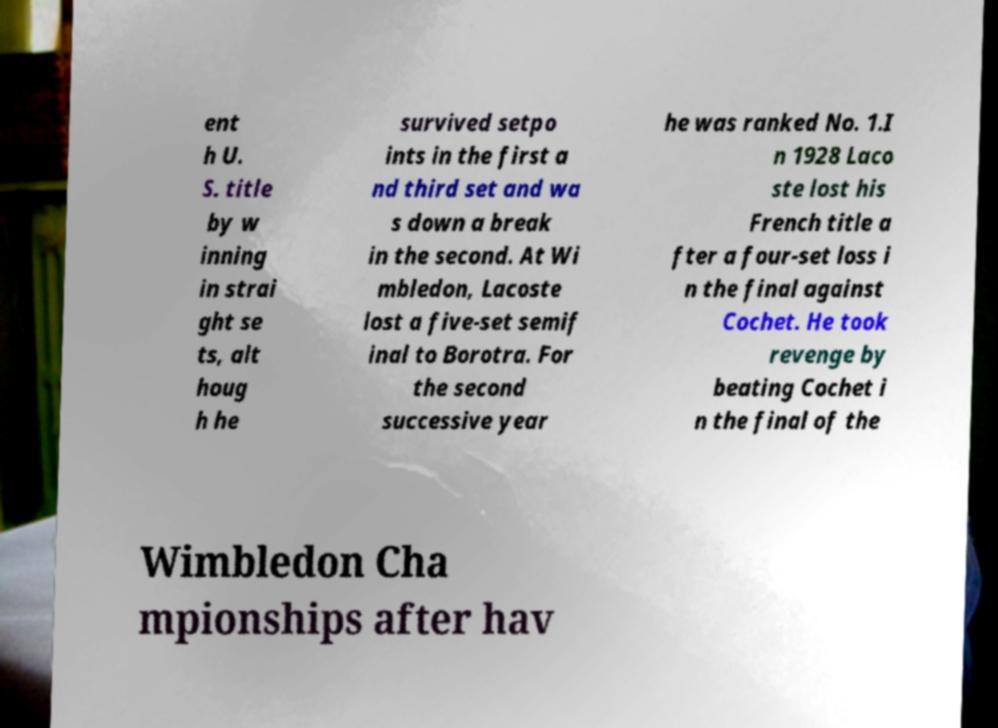Can you accurately transcribe the text from the provided image for me? ent h U. S. title by w inning in strai ght se ts, alt houg h he survived setpo ints in the first a nd third set and wa s down a break in the second. At Wi mbledon, Lacoste lost a five-set semif inal to Borotra. For the second successive year he was ranked No. 1.I n 1928 Laco ste lost his French title a fter a four-set loss i n the final against Cochet. He took revenge by beating Cochet i n the final of the Wimbledon Cha mpionships after hav 